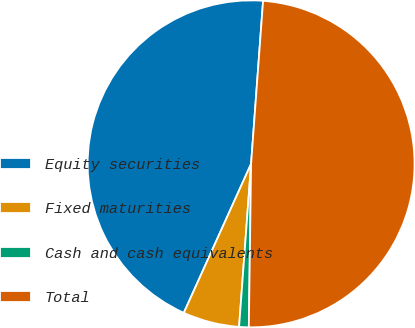Convert chart. <chart><loc_0><loc_0><loc_500><loc_500><pie_chart><fcel>Equity securities<fcel>Fixed maturities<fcel>Cash and cash equivalents<fcel>Total<nl><fcel>44.42%<fcel>5.58%<fcel>0.95%<fcel>49.05%<nl></chart> 